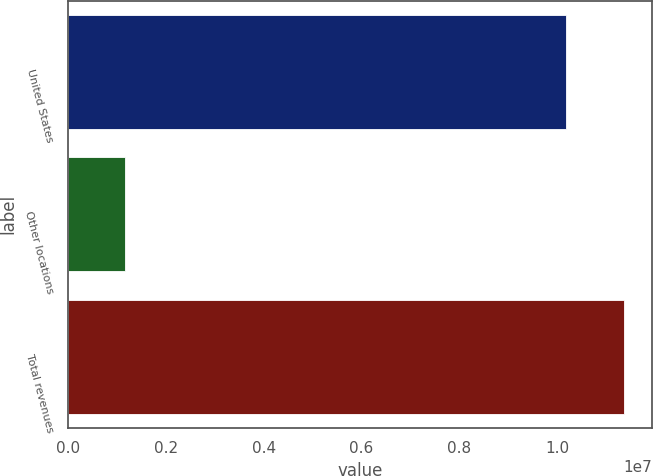Convert chart. <chart><loc_0><loc_0><loc_500><loc_500><bar_chart><fcel>United States<fcel>Other locations<fcel>Total revenues<nl><fcel>1.01836e+07<fcel>1.17552e+06<fcel>1.13591e+07<nl></chart> 